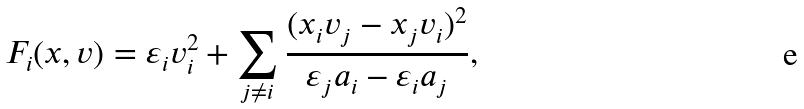Convert formula to latex. <formula><loc_0><loc_0><loc_500><loc_500>F _ { i } ( x , v ) = \varepsilon _ { i } v _ { i } ^ { 2 } + \sum _ { j { \neq } i } \frac { ( x _ { i } v _ { j } - x _ { j } v _ { i } ) ^ { 2 } } { \varepsilon _ { j } a _ { i } - \varepsilon _ { i } a _ { j } } ,</formula> 